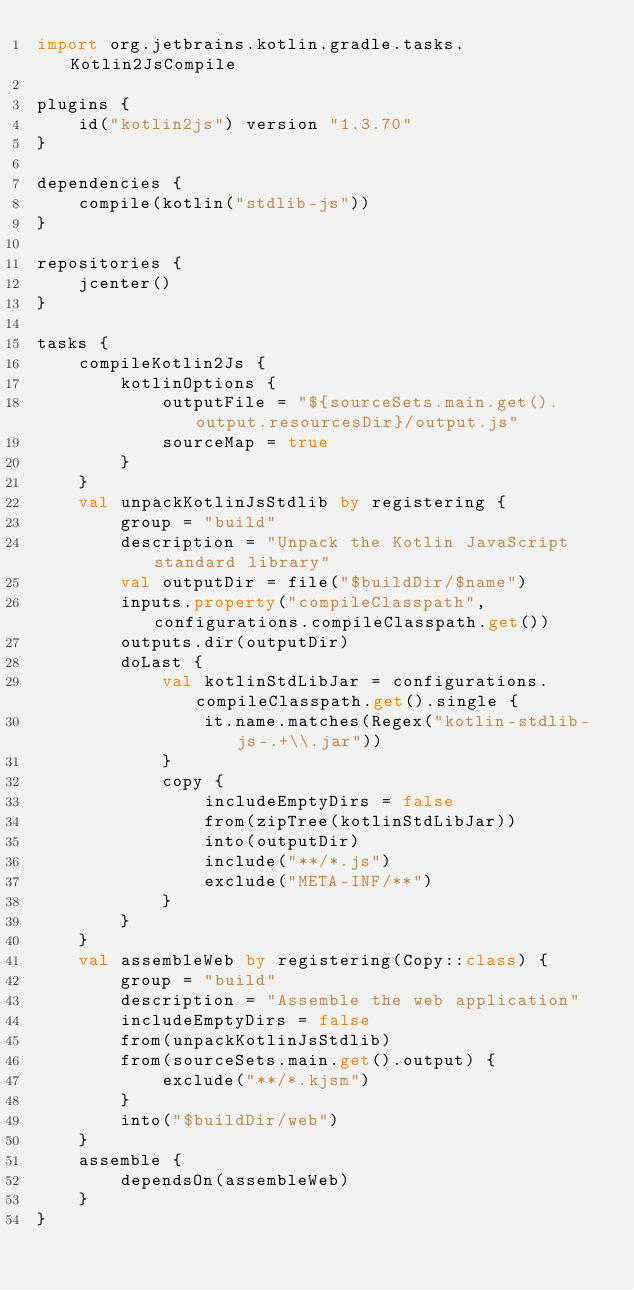Convert code to text. <code><loc_0><loc_0><loc_500><loc_500><_Kotlin_>import org.jetbrains.kotlin.gradle.tasks.Kotlin2JsCompile

plugins {
    id("kotlin2js") version "1.3.70"
}

dependencies {
    compile(kotlin("stdlib-js"))
}

repositories {
    jcenter()
}

tasks {
    compileKotlin2Js {
        kotlinOptions {
            outputFile = "${sourceSets.main.get().output.resourcesDir}/output.js"
            sourceMap = true
        }
    }
    val unpackKotlinJsStdlib by registering {
        group = "build"
        description = "Unpack the Kotlin JavaScript standard library"
        val outputDir = file("$buildDir/$name")
        inputs.property("compileClasspath", configurations.compileClasspath.get())
        outputs.dir(outputDir)
        doLast {
            val kotlinStdLibJar = configurations.compileClasspath.get().single {
                it.name.matches(Regex("kotlin-stdlib-js-.+\\.jar"))
            }
            copy {
                includeEmptyDirs = false
                from(zipTree(kotlinStdLibJar))
                into(outputDir)
                include("**/*.js")
                exclude("META-INF/**")
            }
        }
    }
    val assembleWeb by registering(Copy::class) {
        group = "build"
        description = "Assemble the web application"
        includeEmptyDirs = false
        from(unpackKotlinJsStdlib)
        from(sourceSets.main.get().output) {
            exclude("**/*.kjsm")
        }
        into("$buildDir/web")
    }
    assemble {
        dependsOn(assembleWeb)
    }
}
</code> 